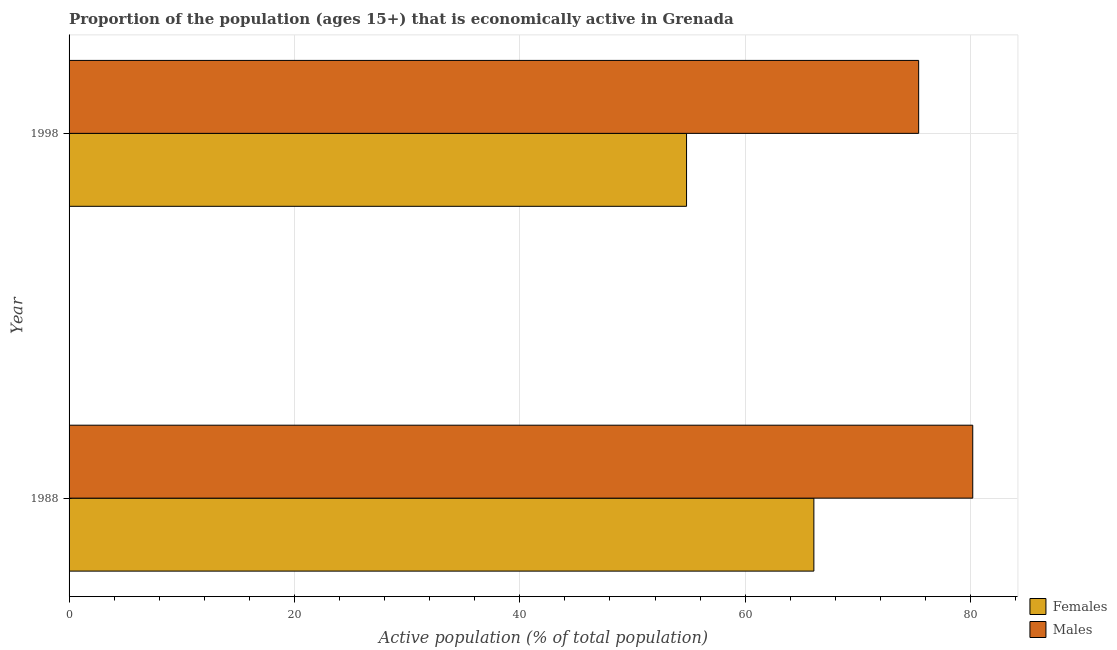How many different coloured bars are there?
Your answer should be very brief. 2. Are the number of bars per tick equal to the number of legend labels?
Provide a succinct answer. Yes. Are the number of bars on each tick of the Y-axis equal?
Make the answer very short. Yes. In how many cases, is the number of bars for a given year not equal to the number of legend labels?
Provide a short and direct response. 0. What is the percentage of economically active female population in 1998?
Make the answer very short. 54.8. Across all years, what is the maximum percentage of economically active female population?
Offer a very short reply. 66.1. Across all years, what is the minimum percentage of economically active female population?
Offer a terse response. 54.8. In which year was the percentage of economically active female population maximum?
Keep it short and to the point. 1988. What is the total percentage of economically active male population in the graph?
Make the answer very short. 155.6. What is the difference between the percentage of economically active male population in 1988 and that in 1998?
Offer a terse response. 4.8. What is the difference between the percentage of economically active male population in 1998 and the percentage of economically active female population in 1988?
Make the answer very short. 9.3. What is the average percentage of economically active male population per year?
Offer a very short reply. 77.8. In the year 1988, what is the difference between the percentage of economically active female population and percentage of economically active male population?
Offer a terse response. -14.1. What is the ratio of the percentage of economically active male population in 1988 to that in 1998?
Your answer should be compact. 1.06. Is the percentage of economically active female population in 1988 less than that in 1998?
Keep it short and to the point. No. Is the difference between the percentage of economically active female population in 1988 and 1998 greater than the difference between the percentage of economically active male population in 1988 and 1998?
Offer a terse response. Yes. In how many years, is the percentage of economically active female population greater than the average percentage of economically active female population taken over all years?
Make the answer very short. 1. What does the 1st bar from the top in 1998 represents?
Your answer should be compact. Males. What does the 1st bar from the bottom in 1988 represents?
Keep it short and to the point. Females. Are all the bars in the graph horizontal?
Ensure brevity in your answer.  Yes. What is the difference between two consecutive major ticks on the X-axis?
Offer a very short reply. 20. Are the values on the major ticks of X-axis written in scientific E-notation?
Make the answer very short. No. Does the graph contain any zero values?
Keep it short and to the point. No. Does the graph contain grids?
Make the answer very short. Yes. Where does the legend appear in the graph?
Offer a terse response. Bottom right. How many legend labels are there?
Your answer should be compact. 2. What is the title of the graph?
Your answer should be compact. Proportion of the population (ages 15+) that is economically active in Grenada. What is the label or title of the X-axis?
Provide a succinct answer. Active population (% of total population). What is the Active population (% of total population) of Females in 1988?
Provide a short and direct response. 66.1. What is the Active population (% of total population) in Males in 1988?
Give a very brief answer. 80.2. What is the Active population (% of total population) of Females in 1998?
Give a very brief answer. 54.8. What is the Active population (% of total population) of Males in 1998?
Provide a succinct answer. 75.4. Across all years, what is the maximum Active population (% of total population) of Females?
Offer a very short reply. 66.1. Across all years, what is the maximum Active population (% of total population) of Males?
Your answer should be compact. 80.2. Across all years, what is the minimum Active population (% of total population) in Females?
Keep it short and to the point. 54.8. Across all years, what is the minimum Active population (% of total population) of Males?
Your answer should be compact. 75.4. What is the total Active population (% of total population) of Females in the graph?
Your answer should be compact. 120.9. What is the total Active population (% of total population) in Males in the graph?
Make the answer very short. 155.6. What is the difference between the Active population (% of total population) in Females in 1988 and the Active population (% of total population) in Males in 1998?
Your answer should be very brief. -9.3. What is the average Active population (% of total population) in Females per year?
Make the answer very short. 60.45. What is the average Active population (% of total population) in Males per year?
Keep it short and to the point. 77.8. In the year 1988, what is the difference between the Active population (% of total population) of Females and Active population (% of total population) of Males?
Your answer should be compact. -14.1. In the year 1998, what is the difference between the Active population (% of total population) in Females and Active population (% of total population) in Males?
Give a very brief answer. -20.6. What is the ratio of the Active population (% of total population) of Females in 1988 to that in 1998?
Provide a succinct answer. 1.21. What is the ratio of the Active population (% of total population) in Males in 1988 to that in 1998?
Your response must be concise. 1.06. What is the difference between the highest and the lowest Active population (% of total population) of Females?
Your answer should be compact. 11.3. 